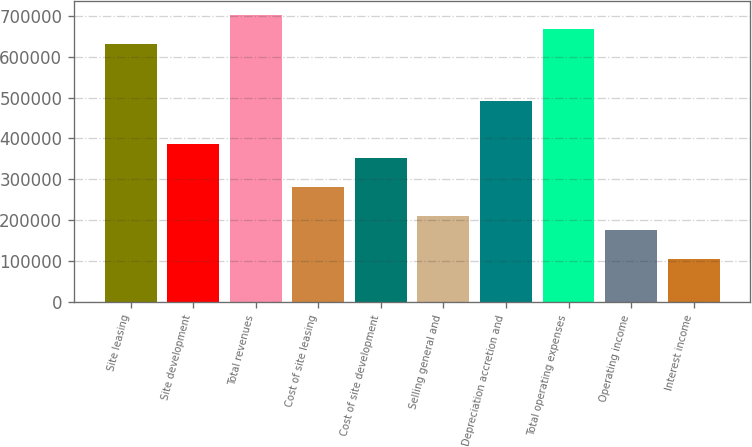<chart> <loc_0><loc_0><loc_500><loc_500><bar_chart><fcel>Site leasing<fcel>Site development<fcel>Total revenues<fcel>Cost of site leasing<fcel>Cost of site development<fcel>Selling general and<fcel>Depreciation accretion and<fcel>Total operating expenses<fcel>Operating income<fcel>Interest income<nl><fcel>631982<fcel>386212<fcel>702203<fcel>280882<fcel>351102<fcel>210662<fcel>491542<fcel>667092<fcel>175552<fcel>105332<nl></chart> 